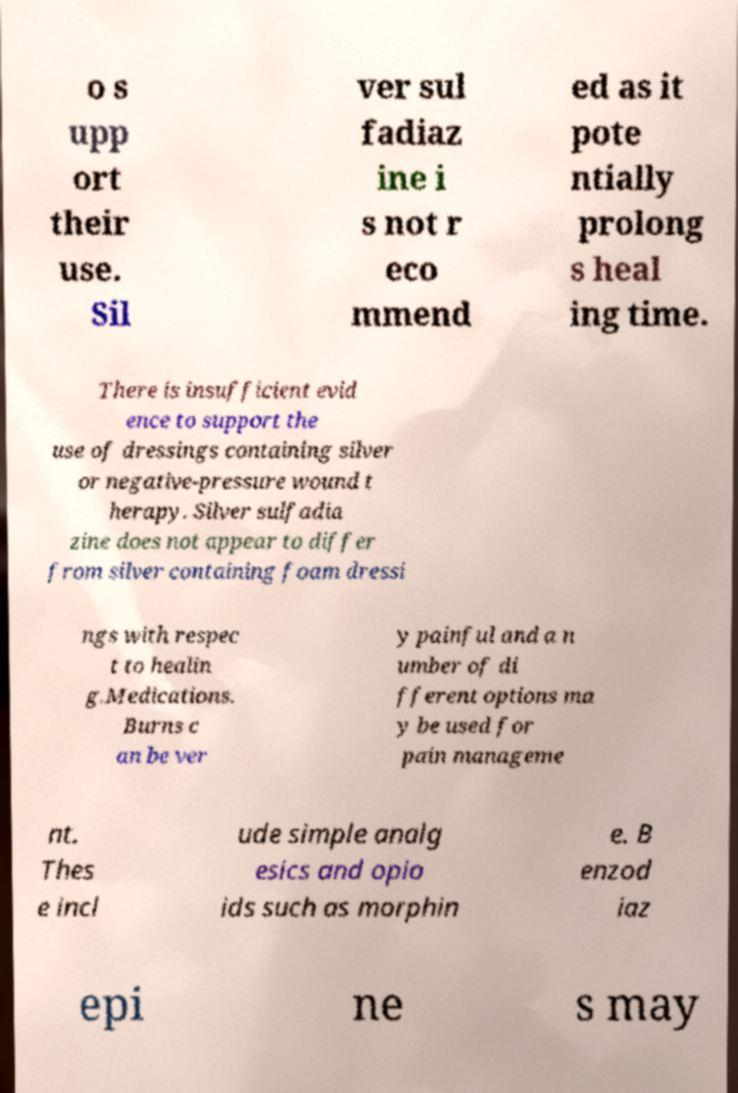For documentation purposes, I need the text within this image transcribed. Could you provide that? o s upp ort their use. Sil ver sul fadiaz ine i s not r eco mmend ed as it pote ntially prolong s heal ing time. There is insufficient evid ence to support the use of dressings containing silver or negative-pressure wound t herapy. Silver sulfadia zine does not appear to differ from silver containing foam dressi ngs with respec t to healin g.Medications. Burns c an be ver y painful and a n umber of di fferent options ma y be used for pain manageme nt. Thes e incl ude simple analg esics and opio ids such as morphin e. B enzod iaz epi ne s may 